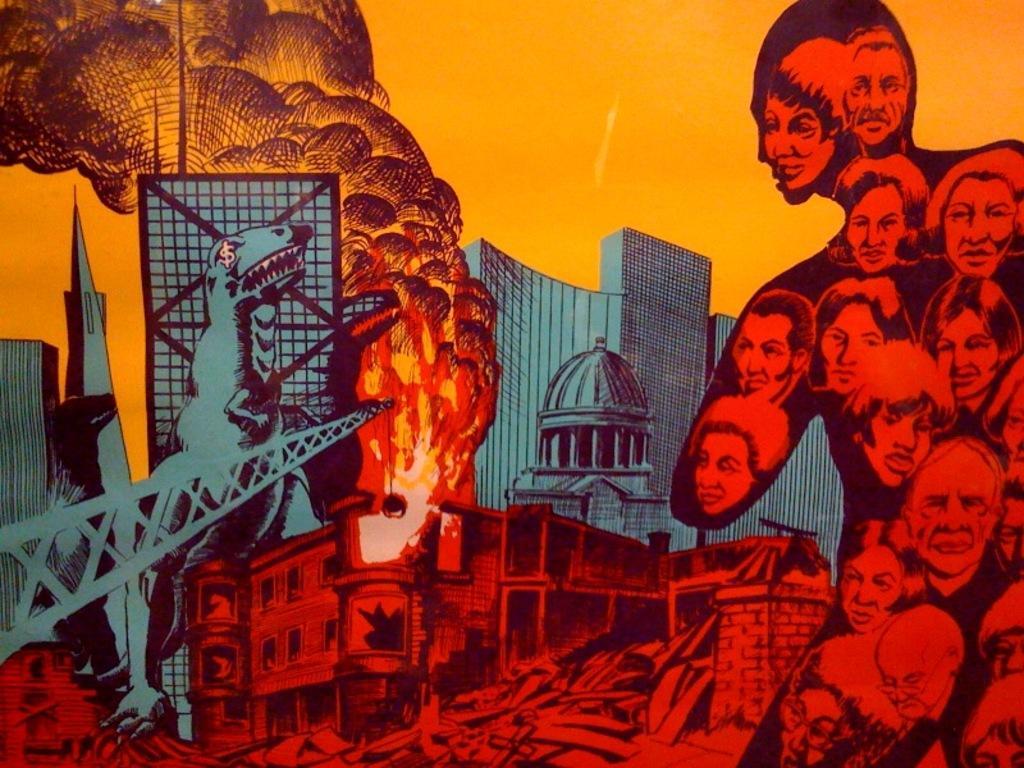Please provide a concise description of this image. In this picture we can see a poster, on this poster we can see heads of people, animals, fire, buildings and sky. 